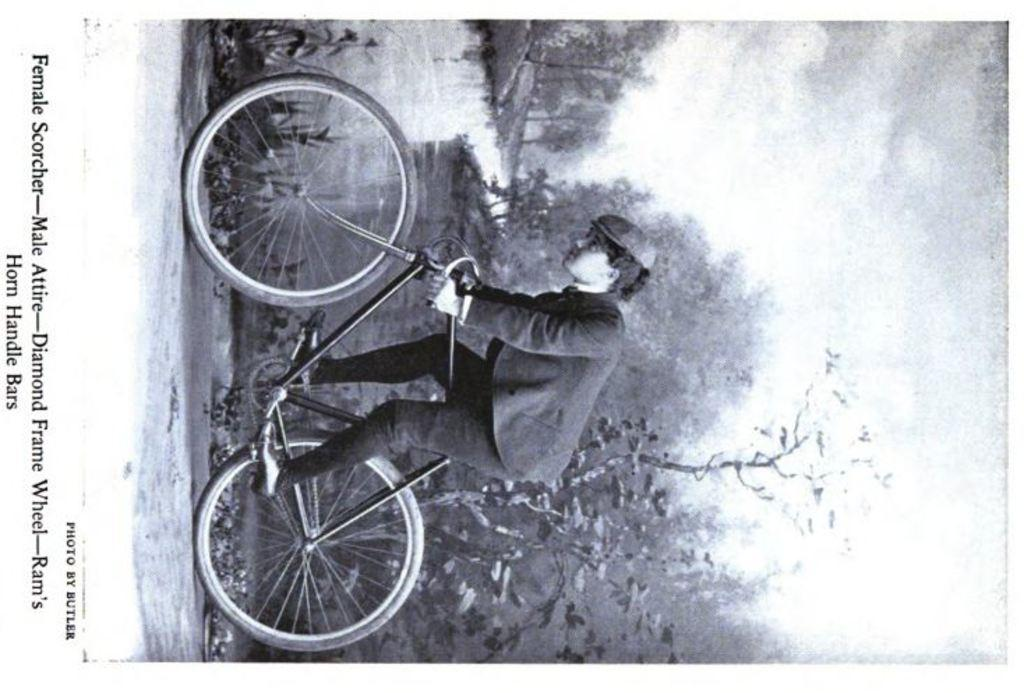What is featured on the poster in the image? The poster depicts a person riding a bicycle. What type of natural environment can be seen in the image? There are trees and water visible in the image. Where is the text located in the image? The text is written on the left side of the image. Can you see a rabbit playing baseball in the sand in the image? No, there is no rabbit, baseball, or sand present in the image. 